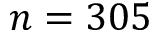Convert formula to latex. <formula><loc_0><loc_0><loc_500><loc_500>n = 3 0 5</formula> 